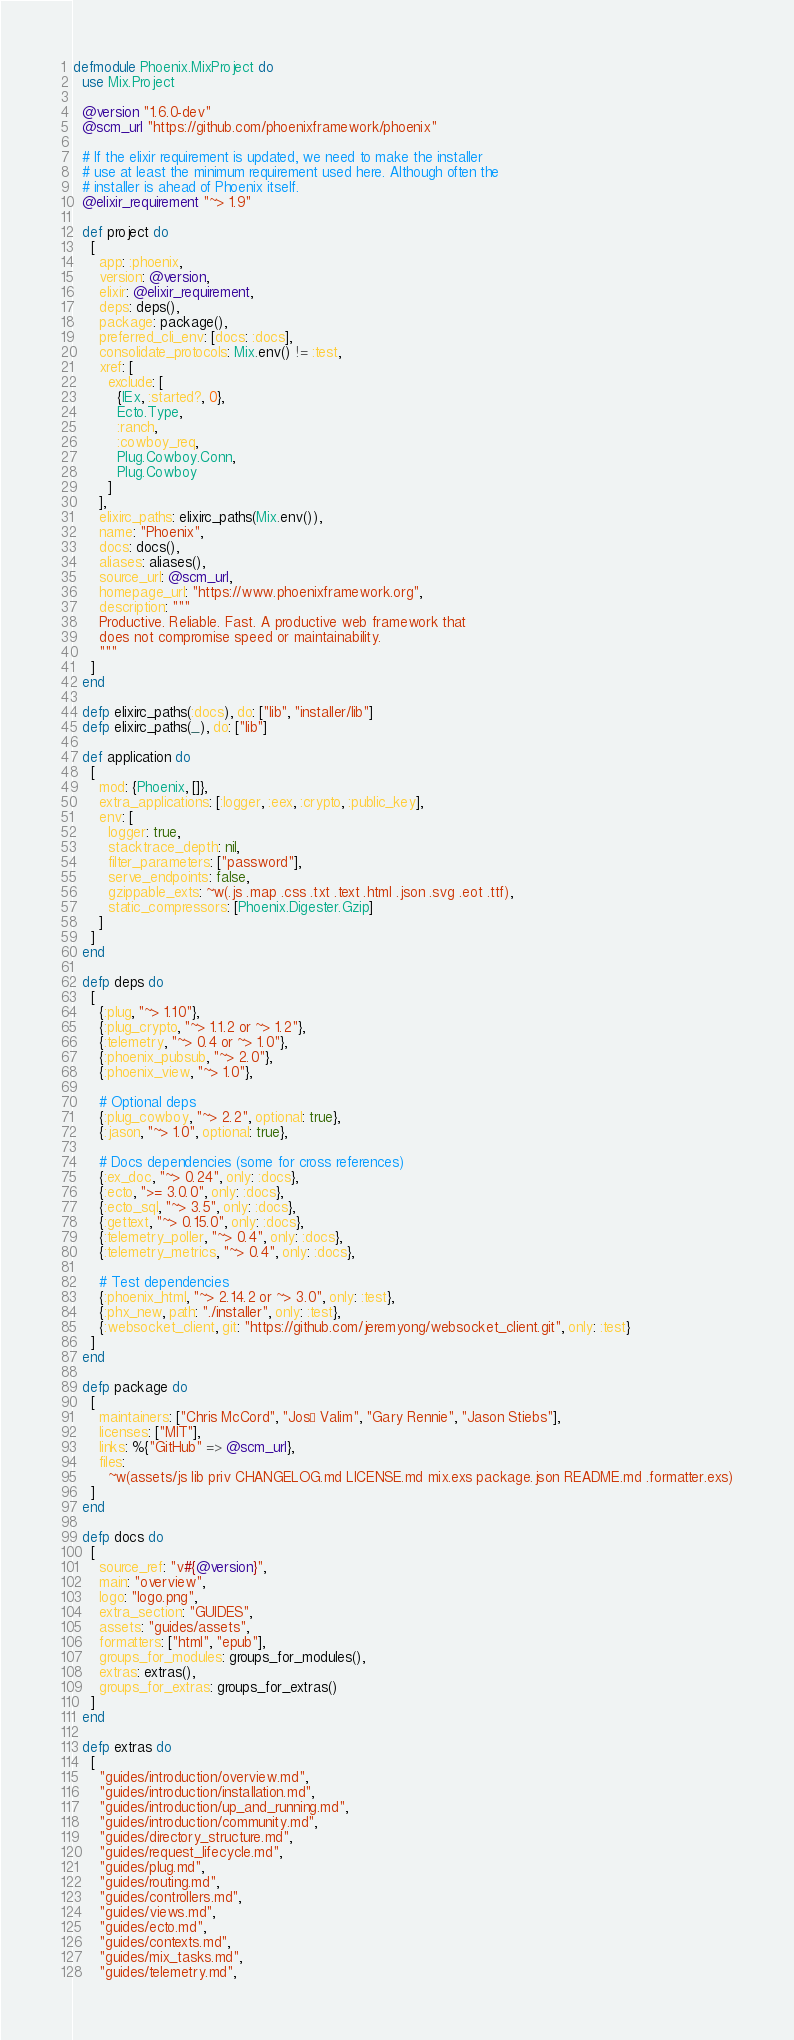Convert code to text. <code><loc_0><loc_0><loc_500><loc_500><_Elixir_>defmodule Phoenix.MixProject do
  use Mix.Project

  @version "1.6.0-dev"
  @scm_url "https://github.com/phoenixframework/phoenix"

  # If the elixir requirement is updated, we need to make the installer
  # use at least the minimum requirement used here. Although often the
  # installer is ahead of Phoenix itself.
  @elixir_requirement "~> 1.9"

  def project do
    [
      app: :phoenix,
      version: @version,
      elixir: @elixir_requirement,
      deps: deps(),
      package: package(),
      preferred_cli_env: [docs: :docs],
      consolidate_protocols: Mix.env() != :test,
      xref: [
        exclude: [
          {IEx, :started?, 0},
          Ecto.Type,
          :ranch,
          :cowboy_req,
          Plug.Cowboy.Conn,
          Plug.Cowboy
        ]
      ],
      elixirc_paths: elixirc_paths(Mix.env()),
      name: "Phoenix",
      docs: docs(),
      aliases: aliases(),
      source_url: @scm_url,
      homepage_url: "https://www.phoenixframework.org",
      description: """
      Productive. Reliable. Fast. A productive web framework that
      does not compromise speed or maintainability.
      """
    ]
  end

  defp elixirc_paths(:docs), do: ["lib", "installer/lib"]
  defp elixirc_paths(_), do: ["lib"]

  def application do
    [
      mod: {Phoenix, []},
      extra_applications: [:logger, :eex, :crypto, :public_key],
      env: [
        logger: true,
        stacktrace_depth: nil,
        filter_parameters: ["password"],
        serve_endpoints: false,
        gzippable_exts: ~w(.js .map .css .txt .text .html .json .svg .eot .ttf),
        static_compressors: [Phoenix.Digester.Gzip]
      ]
    ]
  end

  defp deps do
    [
      {:plug, "~> 1.10"},
      {:plug_crypto, "~> 1.1.2 or ~> 1.2"},
      {:telemetry, "~> 0.4 or ~> 1.0"},
      {:phoenix_pubsub, "~> 2.0"},
      {:phoenix_view, "~> 1.0"},

      # Optional deps
      {:plug_cowboy, "~> 2.2", optional: true},
      {:jason, "~> 1.0", optional: true},

      # Docs dependencies (some for cross references)
      {:ex_doc, "~> 0.24", only: :docs},
      {:ecto, ">= 3.0.0", only: :docs},
      {:ecto_sql, "~> 3.5", only: :docs},
      {:gettext, "~> 0.15.0", only: :docs},
      {:telemetry_poller, "~> 0.4", only: :docs},
      {:telemetry_metrics, "~> 0.4", only: :docs},

      # Test dependencies
      {:phoenix_html, "~> 2.14.2 or ~> 3.0", only: :test},
      {:phx_new, path: "./installer", only: :test},
      {:websocket_client, git: "https://github.com/jeremyong/websocket_client.git", only: :test}
    ]
  end

  defp package do
    [
      maintainers: ["Chris McCord", "José Valim", "Gary Rennie", "Jason Stiebs"],
      licenses: ["MIT"],
      links: %{"GitHub" => @scm_url},
      files:
        ~w(assets/js lib priv CHANGELOG.md LICENSE.md mix.exs package.json README.md .formatter.exs)
    ]
  end

  defp docs do
    [
      source_ref: "v#{@version}",
      main: "overview",
      logo: "logo.png",
      extra_section: "GUIDES",
      assets: "guides/assets",
      formatters: ["html", "epub"],
      groups_for_modules: groups_for_modules(),
      extras: extras(),
      groups_for_extras: groups_for_extras()
    ]
  end

  defp extras do
    [
      "guides/introduction/overview.md",
      "guides/introduction/installation.md",
      "guides/introduction/up_and_running.md",
      "guides/introduction/community.md",
      "guides/directory_structure.md",
      "guides/request_lifecycle.md",
      "guides/plug.md",
      "guides/routing.md",
      "guides/controllers.md",
      "guides/views.md",
      "guides/ecto.md",
      "guides/contexts.md",
      "guides/mix_tasks.md",
      "guides/telemetry.md",</code> 